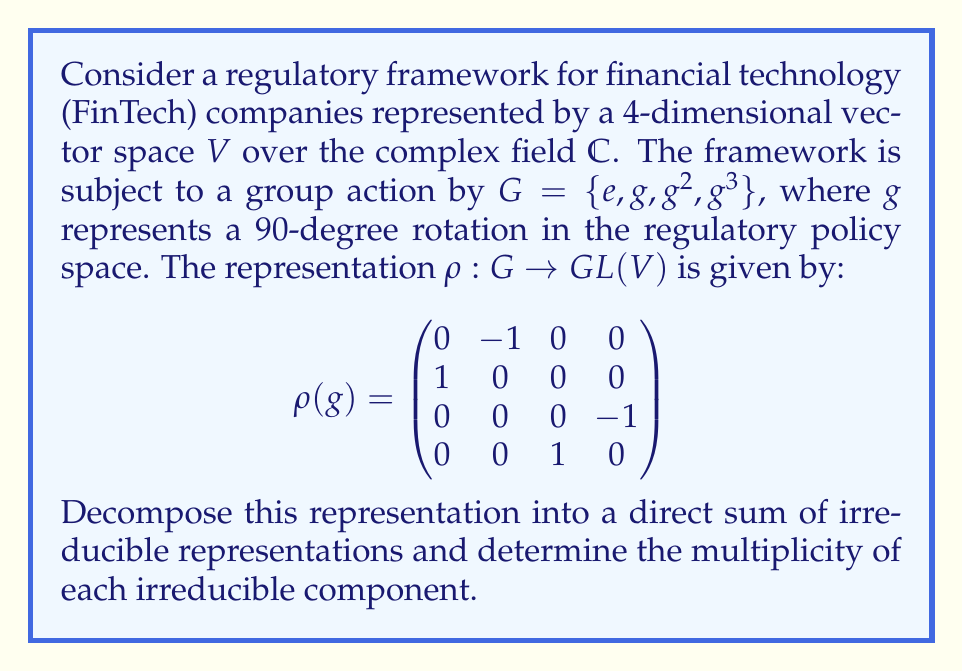Show me your answer to this math problem. To decompose the representation, we follow these steps:

1) First, we need to find the character of the representation. The character $\chi$ is given by the trace of the matrices:

   $\chi(e) = 4$
   $\chi(g) = \chi(g^3) = 0$
   $\chi(g^2) = -2$

2) Now, we need to find the irreducible representations of the cyclic group $C_4$. There are four 1-dimensional irreducible representations:

   $\rho_0(g^k) = 1$
   $\rho_1(g^k) = i^k$
   $\rho_2(g^k) = (-1)^k$
   $\rho_3(g^k) = (-i)^k$

3) We can compute the multiplicities of each irreducible representation using the inner product of characters:

   $m_j = \frac{1}{|G|} \sum_{g \in G} \chi(g) \overline{\chi_j(g)}$

   Where $\chi_j$ is the character of the $j$-th irreducible representation.

4) Calculating each multiplicity:

   $m_0 = \frac{1}{4}(4 + 0 + (-2) + 0) = \frac{1}{2}$
   $m_1 = \frac{1}{4}(4 + 0i + (-2) + 0i) = \frac{1}{2}$
   $m_2 = \frac{1}{4}(4 + 0 + (-2) + 0) = \frac{1}{2}$
   $m_3 = \frac{1}{4}(4 + 0i + (-2) + 0i) = \frac{1}{2}$

5) The multiplicities must be integers, and their sum must equal the dimension of $V$. The only way to achieve this is:

   $m_0 = m_2 = 1$
   $m_1 = m_3 = 1$

Therefore, the representation decomposes as:

$V \cong \rho_0 \oplus \rho_1 \oplus \rho_2 \oplus \rho_3$

This decomposition reflects that the regulatory policy space can be broken down into four independent components, each responding differently to the group action.
Answer: $V \cong \rho_0 \oplus \rho_1 \oplus \rho_2 \oplus \rho_3$ 